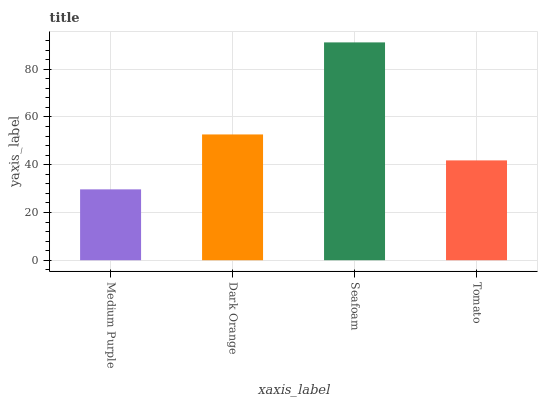Is Medium Purple the minimum?
Answer yes or no. Yes. Is Seafoam the maximum?
Answer yes or no. Yes. Is Dark Orange the minimum?
Answer yes or no. No. Is Dark Orange the maximum?
Answer yes or no. No. Is Dark Orange greater than Medium Purple?
Answer yes or no. Yes. Is Medium Purple less than Dark Orange?
Answer yes or no. Yes. Is Medium Purple greater than Dark Orange?
Answer yes or no. No. Is Dark Orange less than Medium Purple?
Answer yes or no. No. Is Dark Orange the high median?
Answer yes or no. Yes. Is Tomato the low median?
Answer yes or no. Yes. Is Tomato the high median?
Answer yes or no. No. Is Seafoam the low median?
Answer yes or no. No. 